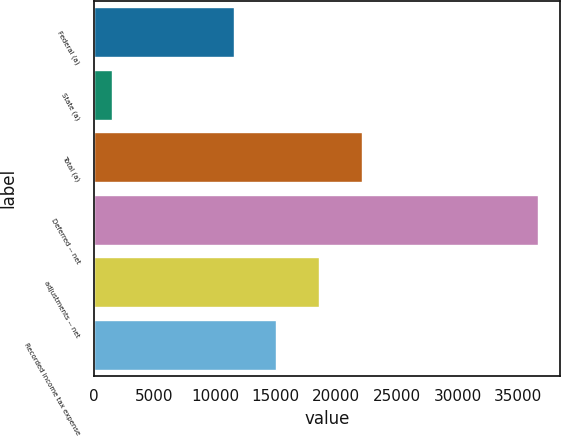Convert chart to OTSL. <chart><loc_0><loc_0><loc_500><loc_500><bar_chart><fcel>Federal (a)<fcel>State (a)<fcel>Total (a)<fcel>Deferred -- net<fcel>adjustments -- net<fcel>Recorded income tax expense<nl><fcel>11535<fcel>1503<fcel>22079.7<fcel>36652<fcel>18564.8<fcel>15049.9<nl></chart> 